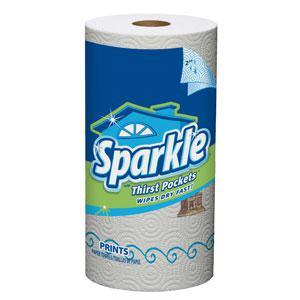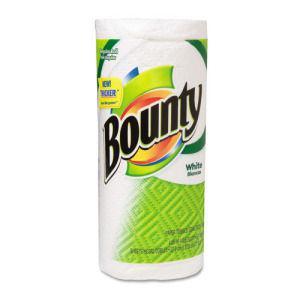The first image is the image on the left, the second image is the image on the right. Examine the images to the left and right. Is the description "One image shows a poster with consumer items in front of it, and the other image shows individiually wrapped paper towel rolls." accurate? Answer yes or no. No. The first image is the image on the left, the second image is the image on the right. Assess this claim about the two images: "One image shows an upright poster for a school science fair project, while a second image shows at least three wrapped rolls of paper towels, all different brands.". Correct or not? Answer yes or no. No. 